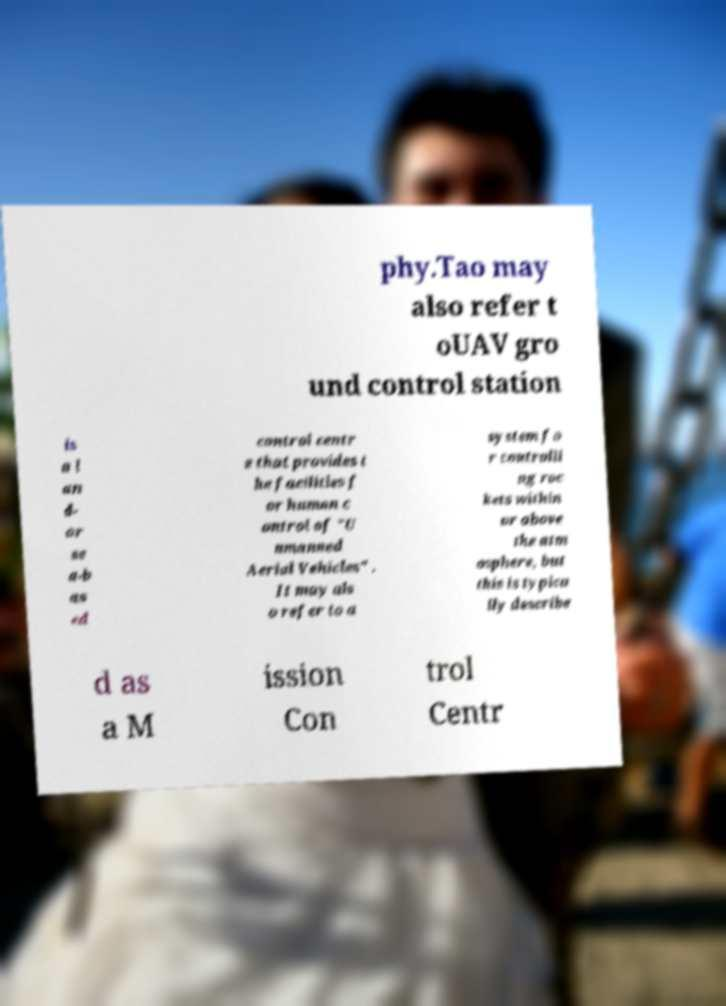I need the written content from this picture converted into text. Can you do that? phy.Tao may also refer t oUAV gro und control station is a l an d- or se a-b as ed control centr e that provides t he facilities f or human c ontrol of "U nmanned Aerial Vehicles" . It may als o refer to a system fo r controlli ng roc kets within or above the atm osphere, but this is typica lly describe d as a M ission Con trol Centr 